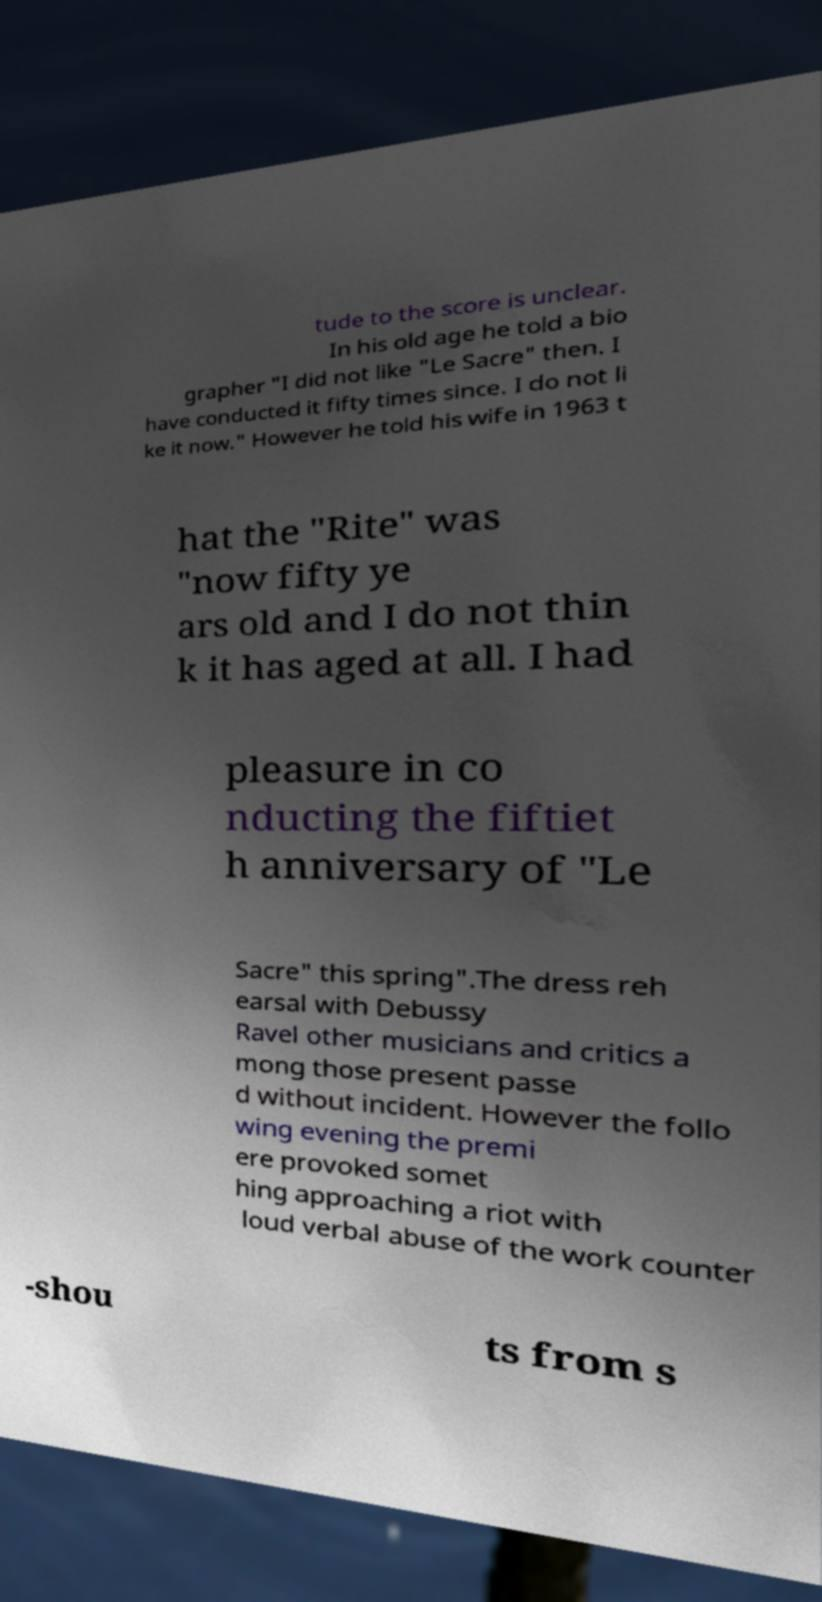Could you extract and type out the text from this image? tude to the score is unclear. In his old age he told a bio grapher "I did not like "Le Sacre" then. I have conducted it fifty times since. I do not li ke it now." However he told his wife in 1963 t hat the "Rite" was "now fifty ye ars old and I do not thin k it has aged at all. I had pleasure in co nducting the fiftiet h anniversary of "Le Sacre" this spring".The dress reh earsal with Debussy Ravel other musicians and critics a mong those present passe d without incident. However the follo wing evening the premi ere provoked somet hing approaching a riot with loud verbal abuse of the work counter -shou ts from s 